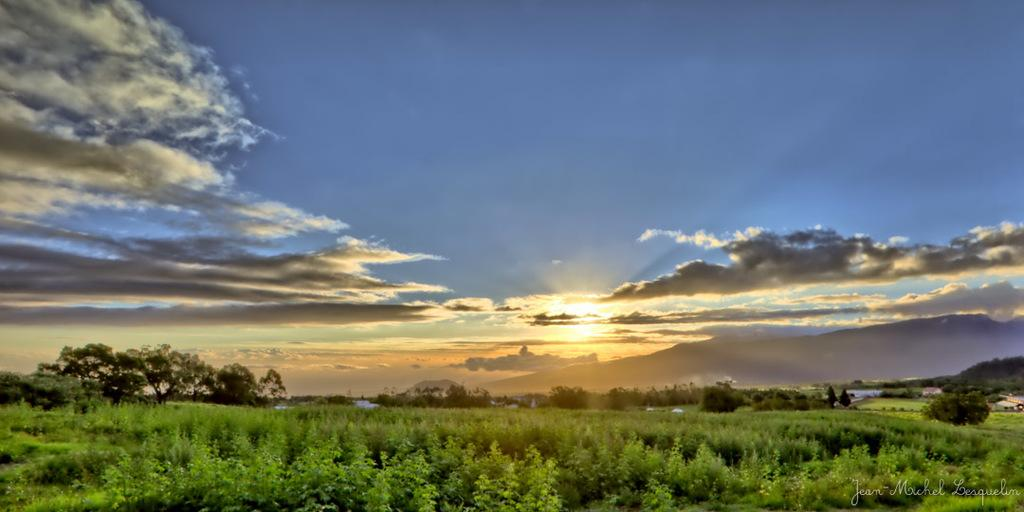What time of day is depicted in the image? The image depicts a sunset. What can be seen at the top of the image? The sky is visible at the top of the image. What type of vegetation is present at the bottom of the image? Trees are present at the bottom of the image. Where is the text located in the image? The text is in the right bottom corner of the image. What type of jar is being used to store the drug in the image? There is no jar or drug present in the image. What scientific experiment is being conducted in the image? There is no scientific experiment depicted in the image. 